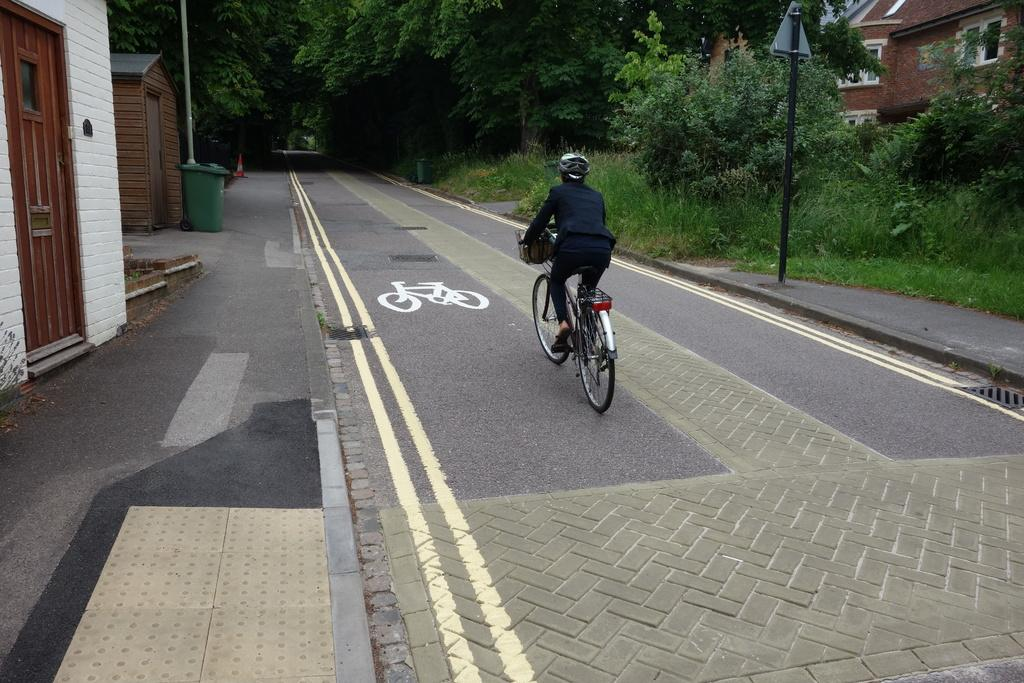What is the person in the image doing? The person is riding a bicycle in the image. Where is the person riding the bicycle? The person is on the road. What can be seen in the background of the image? There are buildings and trees visible in the image. Can you see the seashore in the image? No, there is no seashore visible in the image. 